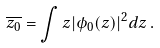<formula> <loc_0><loc_0><loc_500><loc_500>\overline { z _ { 0 } } = \int z | \phi _ { 0 } ( z ) | ^ { 2 } d z \, .</formula> 